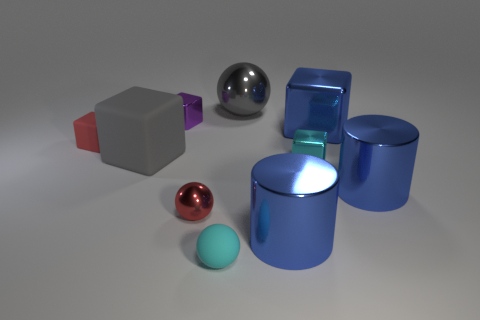Is there a small blue metallic cylinder? Yes, there is a small blue metallic cylinder on the right side of the image, accompanied by other geometric shapes like spheres and cubes. 